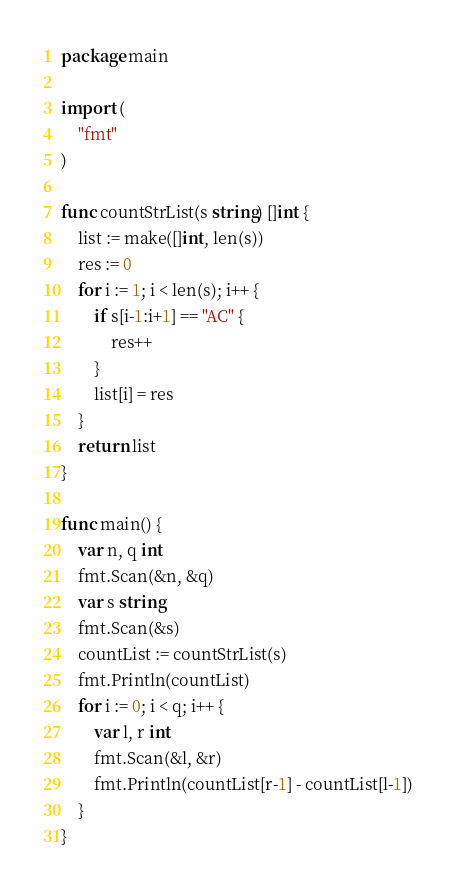<code> <loc_0><loc_0><loc_500><loc_500><_Go_>package main

import (
	"fmt"
)

func countStrList(s string) []int {
	list := make([]int, len(s))
	res := 0
	for i := 1; i < len(s); i++ {
		if s[i-1:i+1] == "AC" {
			res++
		}
		list[i] = res
	}
	return list
}

func main() {
	var n, q int
	fmt.Scan(&n, &q)
	var s string
	fmt.Scan(&s)
	countList := countStrList(s)
	fmt.Println(countList)
	for i := 0; i < q; i++ {
		var l, r int
		fmt.Scan(&l, &r)
		fmt.Println(countList[r-1] - countList[l-1])
	}
}
</code> 